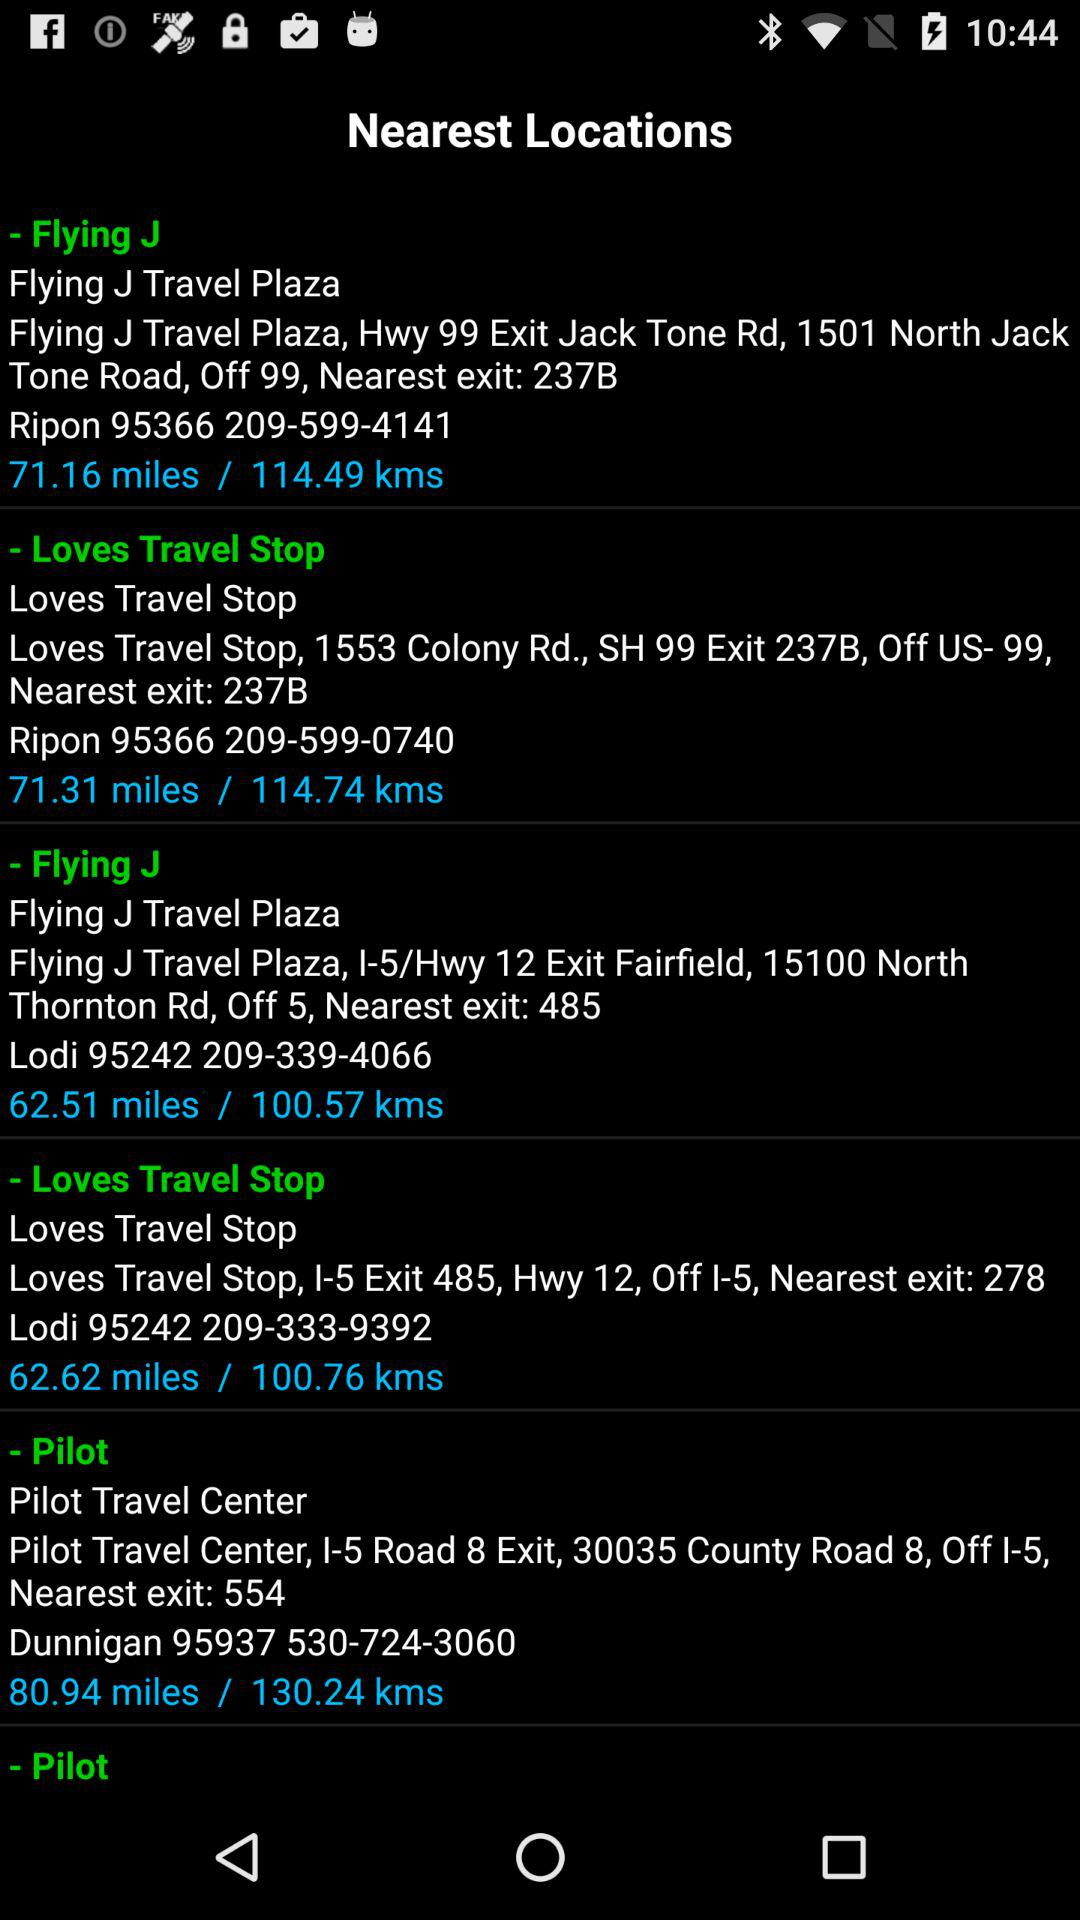What is the nearest exit for "Pilot"? The nearest exit is 554. 